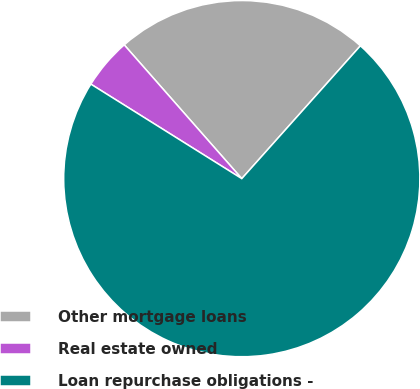<chart> <loc_0><loc_0><loc_500><loc_500><pie_chart><fcel>Other mortgage loans<fcel>Real estate owned<fcel>Loan repurchase obligations -<nl><fcel>23.08%<fcel>4.62%<fcel>72.31%<nl></chart> 